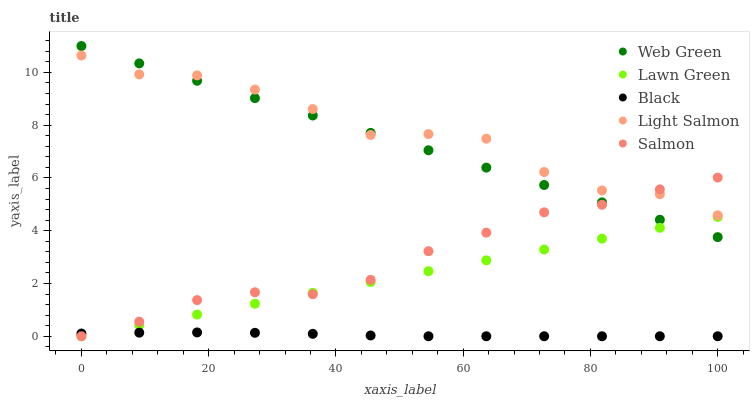Does Black have the minimum area under the curve?
Answer yes or no. Yes. Does Light Salmon have the maximum area under the curve?
Answer yes or no. Yes. Does Light Salmon have the minimum area under the curve?
Answer yes or no. No. Does Black have the maximum area under the curve?
Answer yes or no. No. Is Lawn Green the smoothest?
Answer yes or no. Yes. Is Light Salmon the roughest?
Answer yes or no. Yes. Is Black the smoothest?
Answer yes or no. No. Is Black the roughest?
Answer yes or no. No. Does Lawn Green have the lowest value?
Answer yes or no. Yes. Does Light Salmon have the lowest value?
Answer yes or no. No. Does Web Green have the highest value?
Answer yes or no. Yes. Does Light Salmon have the highest value?
Answer yes or no. No. Is Black less than Web Green?
Answer yes or no. Yes. Is Light Salmon greater than Lawn Green?
Answer yes or no. Yes. Does Web Green intersect Light Salmon?
Answer yes or no. Yes. Is Web Green less than Light Salmon?
Answer yes or no. No. Is Web Green greater than Light Salmon?
Answer yes or no. No. Does Black intersect Web Green?
Answer yes or no. No. 